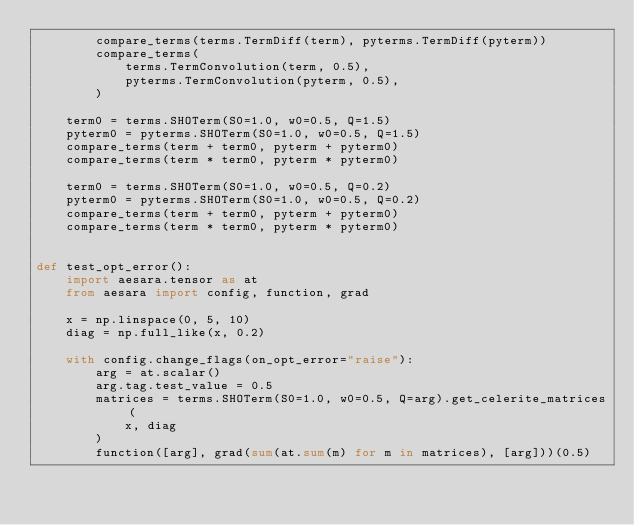<code> <loc_0><loc_0><loc_500><loc_500><_Python_>        compare_terms(terms.TermDiff(term), pyterms.TermDiff(pyterm))
        compare_terms(
            terms.TermConvolution(term, 0.5),
            pyterms.TermConvolution(pyterm, 0.5),
        )

    term0 = terms.SHOTerm(S0=1.0, w0=0.5, Q=1.5)
    pyterm0 = pyterms.SHOTerm(S0=1.0, w0=0.5, Q=1.5)
    compare_terms(term + term0, pyterm + pyterm0)
    compare_terms(term * term0, pyterm * pyterm0)

    term0 = terms.SHOTerm(S0=1.0, w0=0.5, Q=0.2)
    pyterm0 = pyterms.SHOTerm(S0=1.0, w0=0.5, Q=0.2)
    compare_terms(term + term0, pyterm + pyterm0)
    compare_terms(term * term0, pyterm * pyterm0)


def test_opt_error():
    import aesara.tensor as at
    from aesara import config, function, grad

    x = np.linspace(0, 5, 10)
    diag = np.full_like(x, 0.2)

    with config.change_flags(on_opt_error="raise"):
        arg = at.scalar()
        arg.tag.test_value = 0.5
        matrices = terms.SHOTerm(S0=1.0, w0=0.5, Q=arg).get_celerite_matrices(
            x, diag
        )
        function([arg], grad(sum(at.sum(m) for m in matrices), [arg]))(0.5)
</code> 